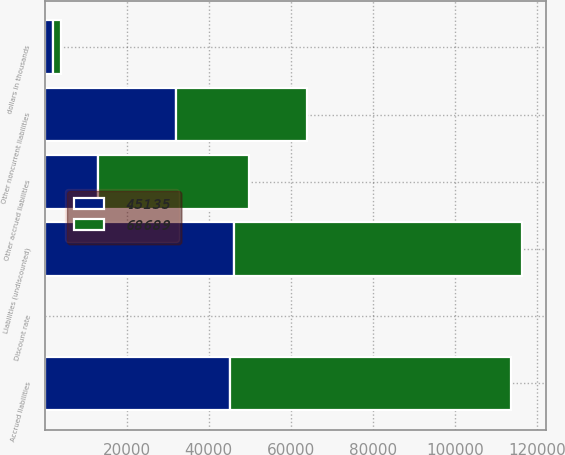Convert chart to OTSL. <chart><loc_0><loc_0><loc_500><loc_500><stacked_bar_chart><ecel><fcel>dollars in thousands<fcel>Liabilities (undiscounted)<fcel>Discount rate<fcel>Other accrued liabilities<fcel>Other noncurrent liabilities<fcel>Accrued liabilities<nl><fcel>45135<fcel>2011<fcel>46178<fcel>0.65<fcel>13046<fcel>32089<fcel>45135<nl><fcel>68689<fcel>2010<fcel>70174<fcel>1.01<fcel>36699<fcel>31990<fcel>68689<nl></chart> 